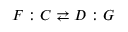Convert formula to latex. <formula><loc_0><loc_0><loc_500><loc_500>F \colon C \right l e f t a r r o w s D \colon G</formula> 